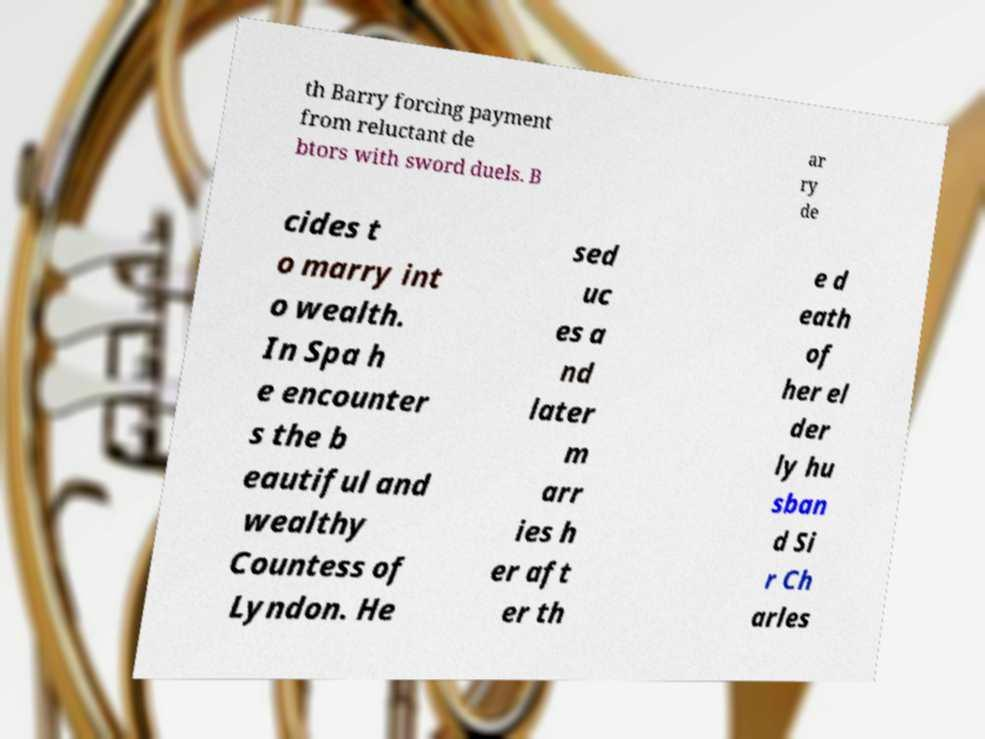Could you extract and type out the text from this image? th Barry forcing payment from reluctant de btors with sword duels. B ar ry de cides t o marry int o wealth. In Spa h e encounter s the b eautiful and wealthy Countess of Lyndon. He sed uc es a nd later m arr ies h er aft er th e d eath of her el der ly hu sban d Si r Ch arles 